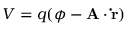<formula> <loc_0><loc_0><loc_500><loc_500>V = q ( \phi - A \cdot \dot { r } )</formula> 